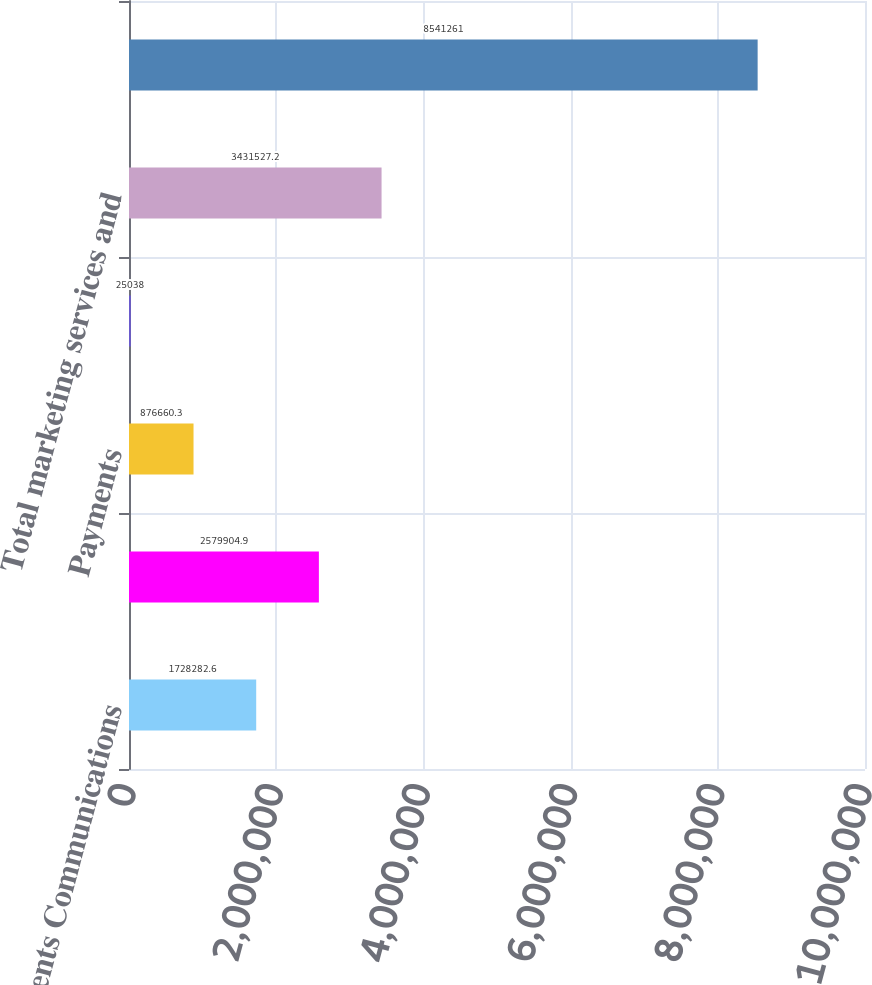Convert chart. <chart><loc_0><loc_0><loc_500><loc_500><bar_chart><fcel>Payments Communications<fcel>Marketplaces<fcel>Payments<fcel>Communications<fcel>Total marketing services and<fcel>Total net revenues<nl><fcel>1.72828e+06<fcel>2.5799e+06<fcel>876660<fcel>25038<fcel>3.43153e+06<fcel>8.54126e+06<nl></chart> 